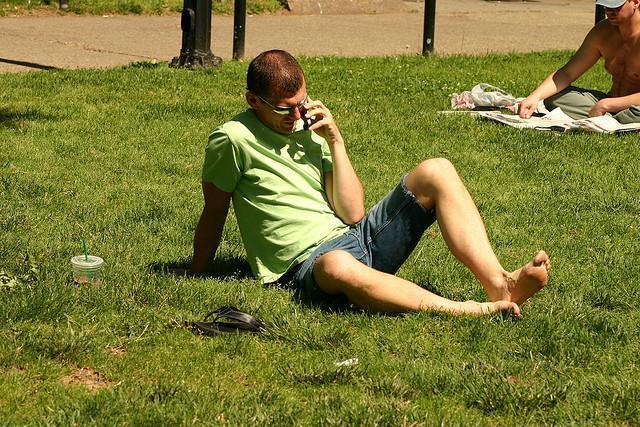How many people are visible?
Give a very brief answer. 2. 